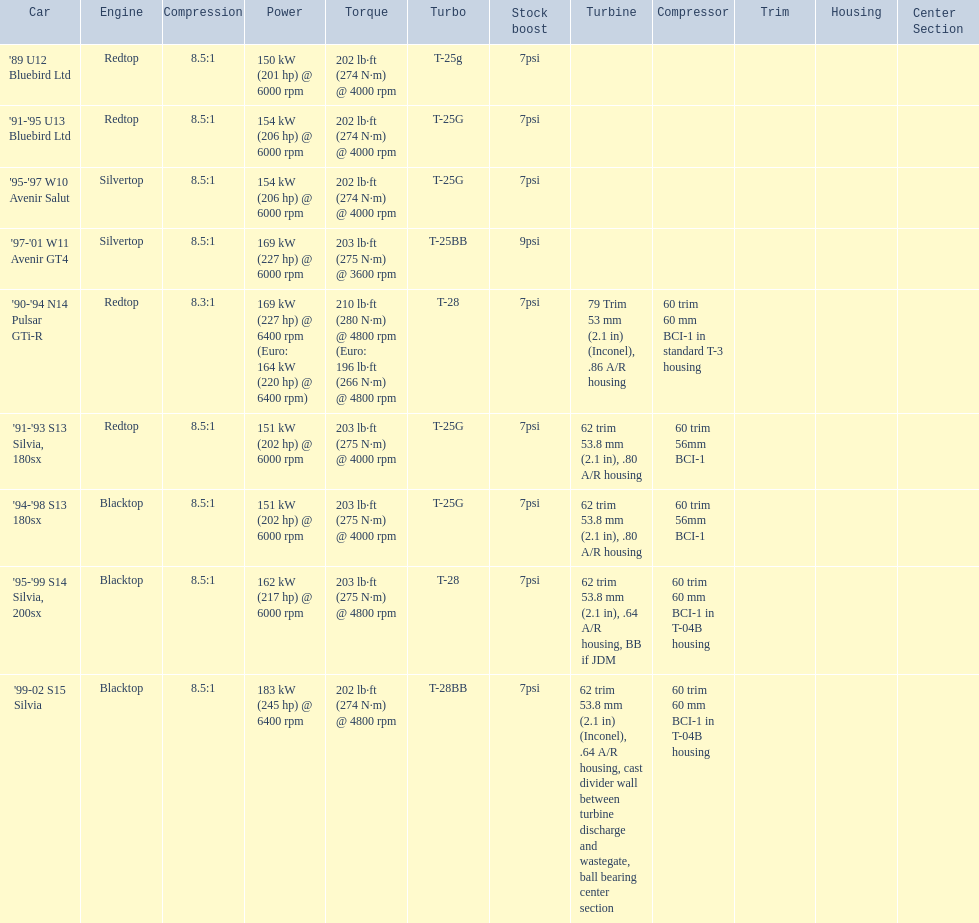What cars are there? '89 U12 Bluebird Ltd, 7psi, '91-'95 U13 Bluebird Ltd, 7psi, '95-'97 W10 Avenir Salut, 7psi, '97-'01 W11 Avenir GT4, 9psi, '90-'94 N14 Pulsar GTi-R, 7psi, '91-'93 S13 Silvia, 180sx, 7psi, '94-'98 S13 180sx, 7psi, '95-'99 S14 Silvia, 200sx, 7psi, '99-02 S15 Silvia, 7psi. Which stock boost is over 7psi? '97-'01 W11 Avenir GT4, 9psi. What car is it? '97-'01 W11 Avenir GT4. 